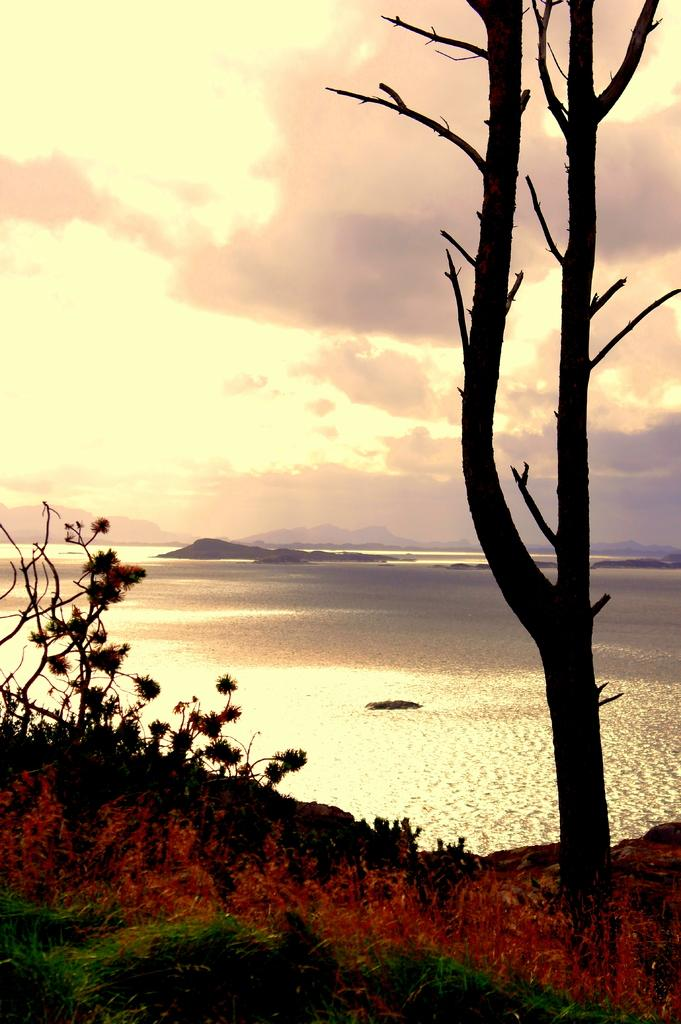What is present at the bottom of the image? There is fire at the bottom of the image. What type of vegetation can be seen in the image? There are plants and a tree in the image. What can be seen in the background of the image? There are hills, water, and the sky visible in the background of the image. What is the condition of the sky in the image? The sky is visible in the background of the image, and there are clouds present. What attraction can be seen in the image? There is no attraction present in the image; it features fire, plants, a tree, hills, water, and the sky. Can you tell me how many times the tree is smashed in the image? There is no tree smashing in the image; the tree is standing upright on the right side. 